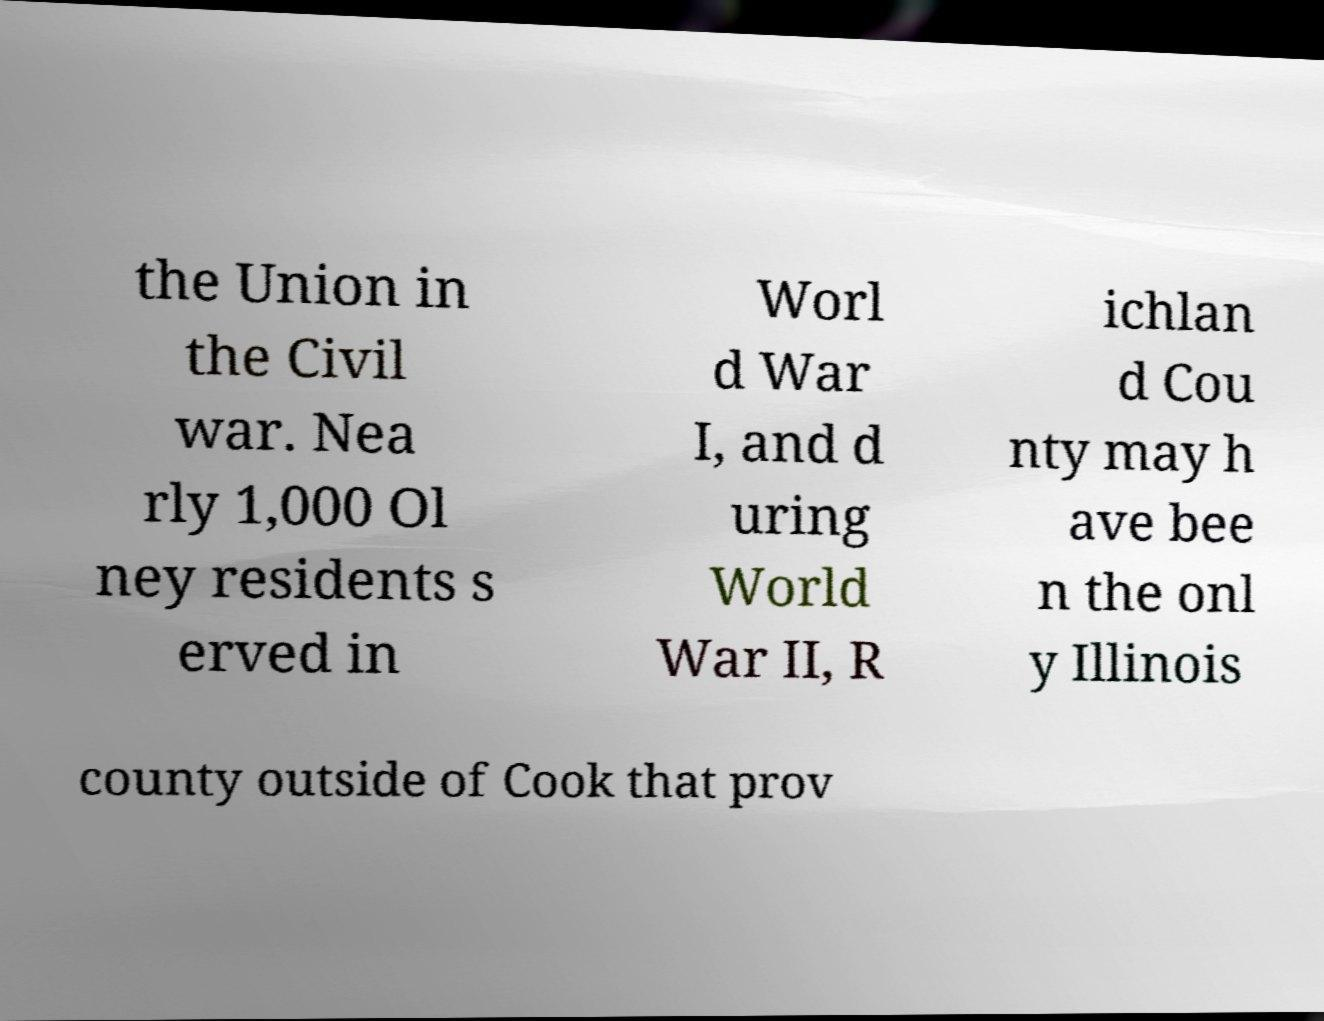Can you accurately transcribe the text from the provided image for me? the Union in the Civil war. Nea rly 1,000 Ol ney residents s erved in Worl d War I, and d uring World War II, R ichlan d Cou nty may h ave bee n the onl y Illinois county outside of Cook that prov 